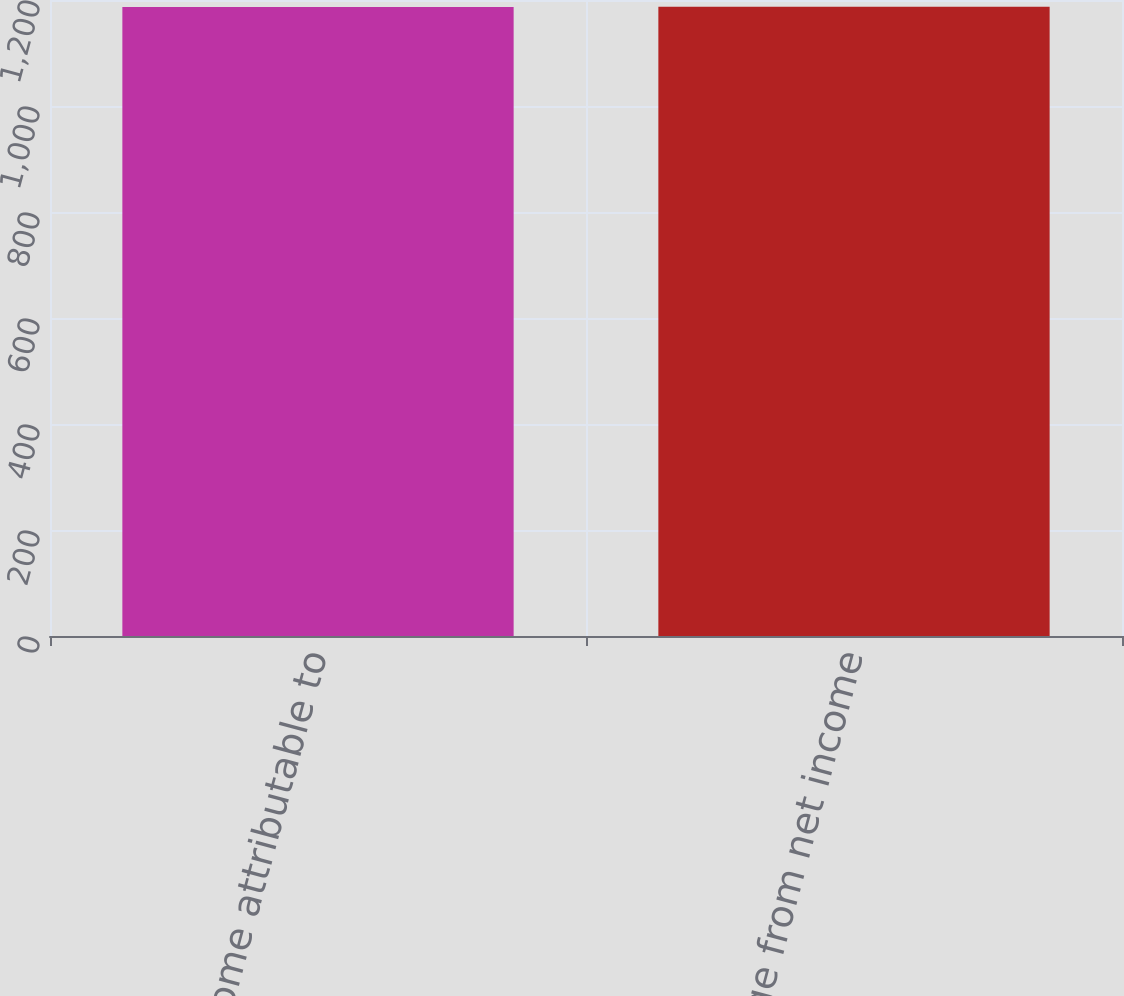<chart> <loc_0><loc_0><loc_500><loc_500><bar_chart><fcel>Net income attributable to<fcel>Change from net income<nl><fcel>1187<fcel>1187.1<nl></chart> 